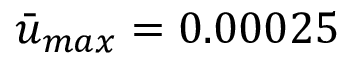<formula> <loc_0><loc_0><loc_500><loc_500>\ B a r { u } _ { \max } = 0 . 0 0 0 2 5</formula> 